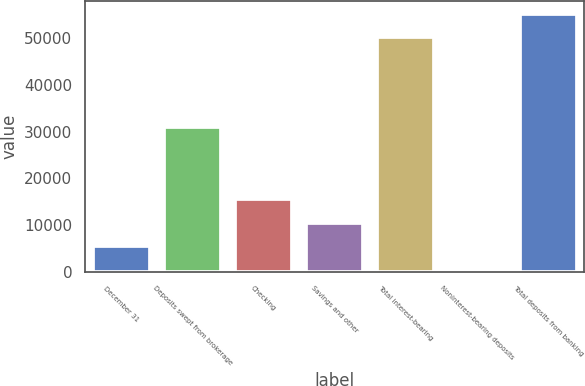<chart> <loc_0><loc_0><loc_500><loc_500><bar_chart><fcel>December 31<fcel>Deposits swept from brokerage<fcel>Checking<fcel>Savings and other<fcel>Total interest-bearing<fcel>Noninterest-bearing deposits<fcel>Total deposits from banking<nl><fcel>5490.1<fcel>30980<fcel>15512.3<fcel>10501.2<fcel>50111<fcel>479<fcel>55122.1<nl></chart> 